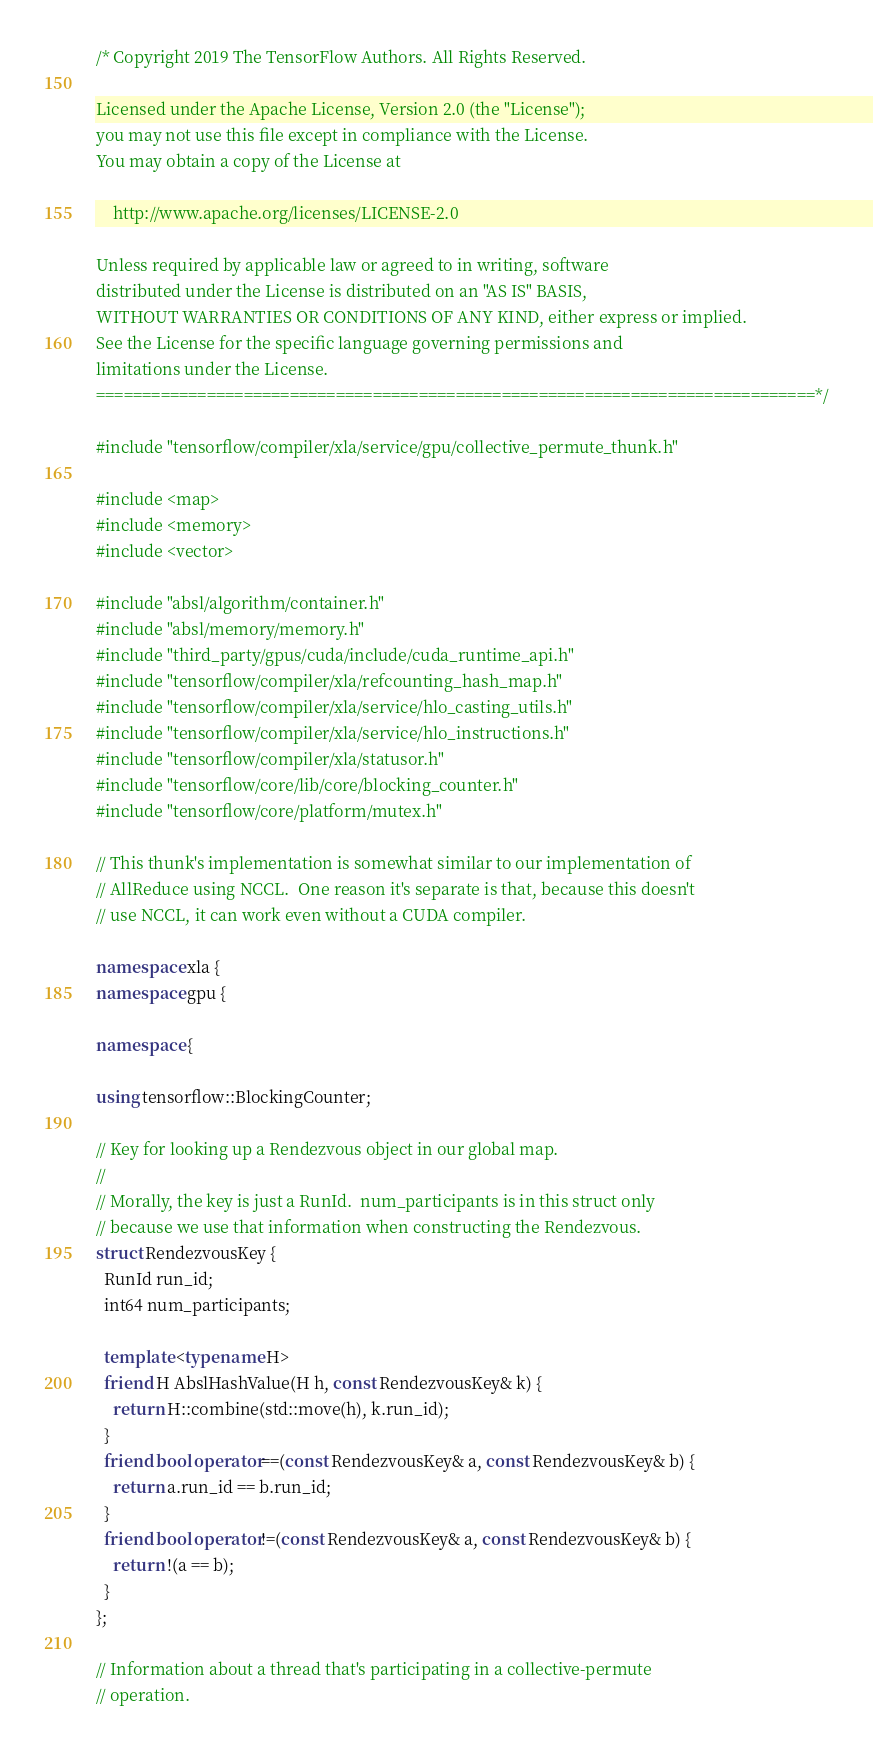<code> <loc_0><loc_0><loc_500><loc_500><_C++_>/* Copyright 2019 The TensorFlow Authors. All Rights Reserved.

Licensed under the Apache License, Version 2.0 (the "License");
you may not use this file except in compliance with the License.
You may obtain a copy of the License at

    http://www.apache.org/licenses/LICENSE-2.0

Unless required by applicable law or agreed to in writing, software
distributed under the License is distributed on an "AS IS" BASIS,
WITHOUT WARRANTIES OR CONDITIONS OF ANY KIND, either express or implied.
See the License for the specific language governing permissions and
limitations under the License.
==============================================================================*/

#include "tensorflow/compiler/xla/service/gpu/collective_permute_thunk.h"

#include <map>
#include <memory>
#include <vector>

#include "absl/algorithm/container.h"
#include "absl/memory/memory.h"
#include "third_party/gpus/cuda/include/cuda_runtime_api.h"
#include "tensorflow/compiler/xla/refcounting_hash_map.h"
#include "tensorflow/compiler/xla/service/hlo_casting_utils.h"
#include "tensorflow/compiler/xla/service/hlo_instructions.h"
#include "tensorflow/compiler/xla/statusor.h"
#include "tensorflow/core/lib/core/blocking_counter.h"
#include "tensorflow/core/platform/mutex.h"

// This thunk's implementation is somewhat similar to our implementation of
// AllReduce using NCCL.  One reason it's separate is that, because this doesn't
// use NCCL, it can work even without a CUDA compiler.

namespace xla {
namespace gpu {

namespace {

using tensorflow::BlockingCounter;

// Key for looking up a Rendezvous object in our global map.
//
// Morally, the key is just a RunId.  num_participants is in this struct only
// because we use that information when constructing the Rendezvous.
struct RendezvousKey {
  RunId run_id;
  int64 num_participants;

  template <typename H>
  friend H AbslHashValue(H h, const RendezvousKey& k) {
    return H::combine(std::move(h), k.run_id);
  }
  friend bool operator==(const RendezvousKey& a, const RendezvousKey& b) {
    return a.run_id == b.run_id;
  }
  friend bool operator!=(const RendezvousKey& a, const RendezvousKey& b) {
    return !(a == b);
  }
};

// Information about a thread that's participating in a collective-permute
// operation.</code> 